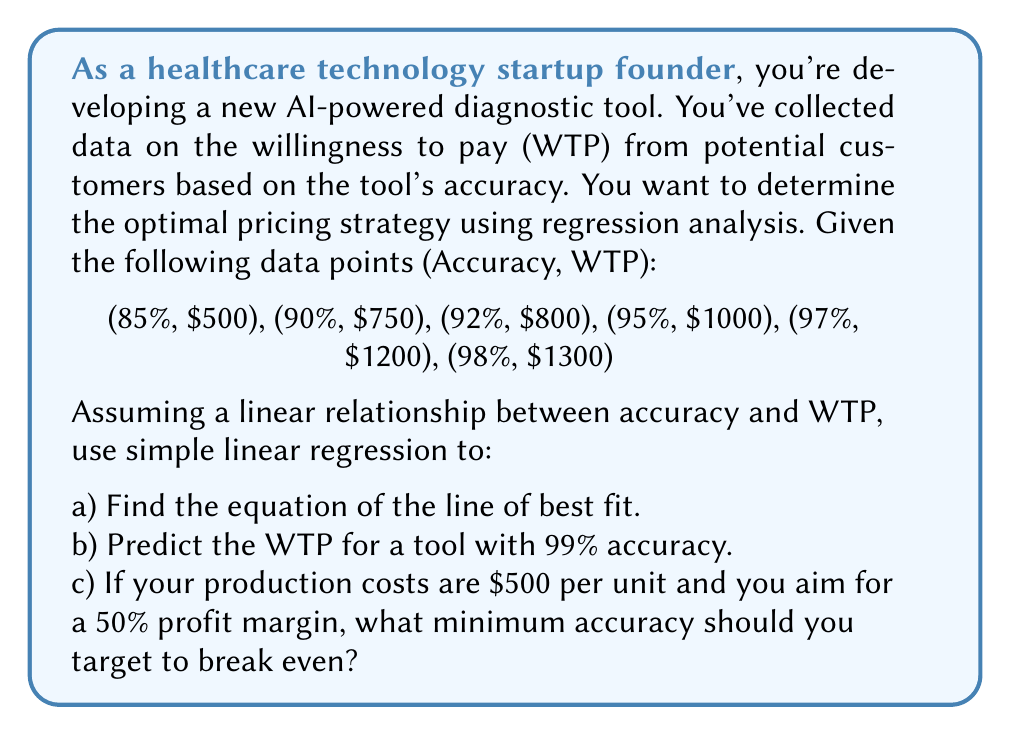Provide a solution to this math problem. Let's approach this step-by-step using simple linear regression.

1) First, we need to set up our variables:
   Let x = Accuracy (as a decimal), y = WTP

   Our data points are:
   (0.85, 500), (0.90, 750), (0.92, 800), (0.95, 1000), (0.97, 1200), (0.98, 1300)

2) To find the line of best fit (y = mx + b), we need to calculate m (slope) and b (y-intercept).

3) The formulas for m and b are:

   $$m = \frac{n\sum{xy} - \sum{x}\sum{y}}{n\sum{x^2} - (\sum{x})^2}$$

   $$b = \frac{\sum{y} - m\sum{x}}{n}$$

   where n is the number of data points.

4) Let's calculate the necessary sums:
   
   $n = 6$
   $\sum{x} = 5.57$
   $\sum{y} = 5550$
   $\sum{xy} = 5225.5$
   $\sum{x^2} = 5.1949$
   $(\sum{x})^2 = 31.0249$

5) Plugging these into our formulas:

   $$m = \frac{6(5225.5) - 5.57(5550)}{6(5.1949) - 31.0249} = 6153.85$$

   $$b = \frac{5550 - 6153.85(5.57)}{6} = -4730.77$$

6) Therefore, our line of best fit is:
   
   $$y = 6153.85x - 4730.77$$

7) To predict the WTP for 99% accuracy:
   
   $$y = 6153.85(0.99) - 4730.77 = 1361.54$$

8) To find the minimum accuracy to break even:
   Cost per unit = $500
   Desired price = $500 * 1.5 = $750 (to achieve 50% profit margin)

   Solve for x:
   $$750 = 6153.85x - 4730.77$$
   $$5480.77 = 6153.85x$$
   $$x = 0.8908 = 89.08\%$$
Answer: a) Line of best fit: y = 6153.85x - 4730.77
b) Predicted WTP for 99% accuracy: $1361.54
c) Minimum accuracy to break even: 89.08% 